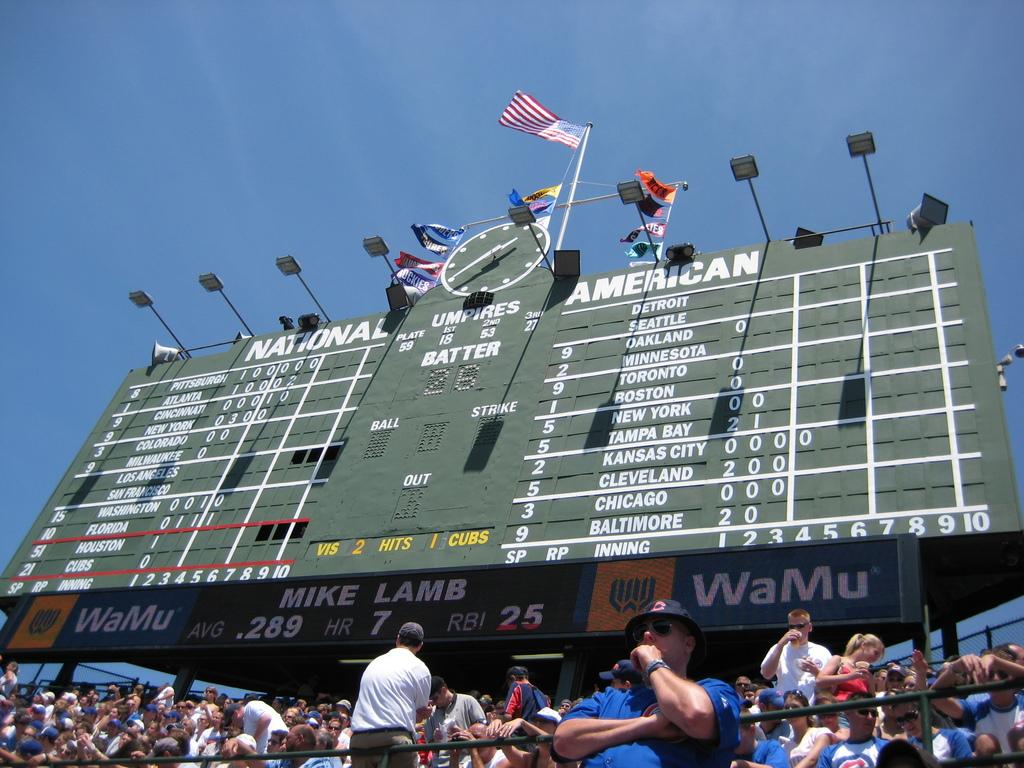<image>
Provide a brief description of the given image. Large scoreboard at a baseball game which says NATIONAL AMERICAN on top. 